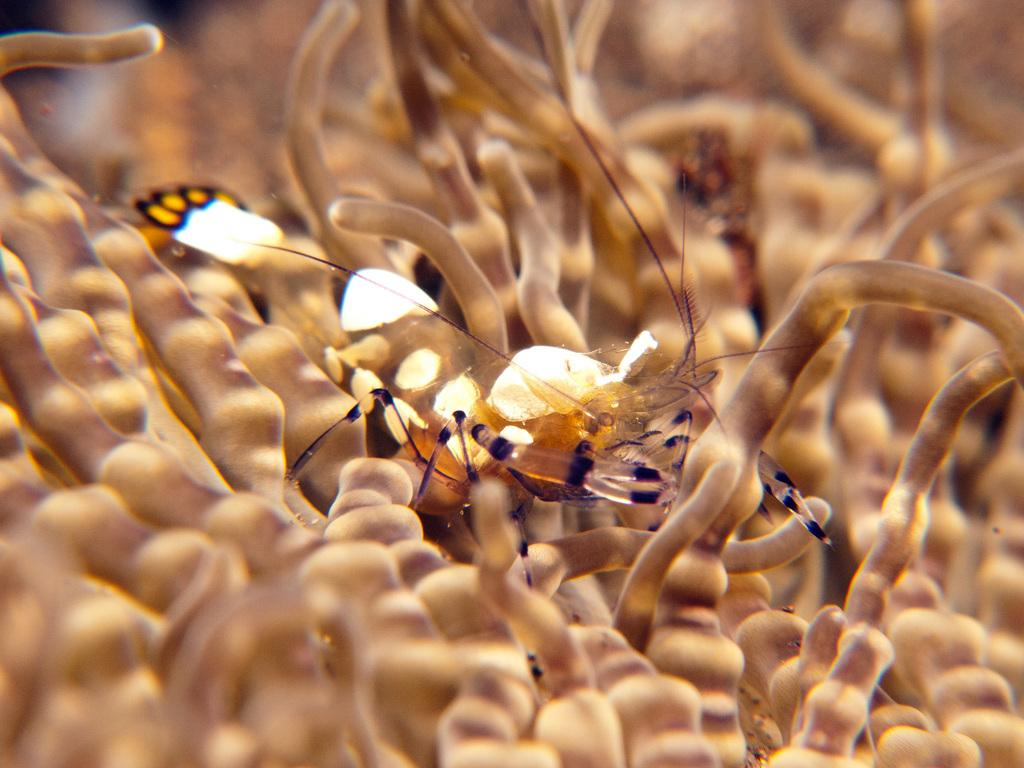What type of creature is present in the image? There is an insect in the image. Where is the insect located? The insect is on an aquatic plant. What type of sign can be seen hanging from the jar in the image? There is no jar or sign present in the image; it only features an insect on an aquatic plant. 